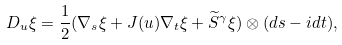<formula> <loc_0><loc_0><loc_500><loc_500>D _ { u } \xi = \frac { 1 } { 2 } ( \nabla _ { s } \xi + J ( u ) \nabla _ { t } \xi + \widetilde { S } ^ { \gamma } \xi ) \otimes ( d s - i d t ) ,</formula> 